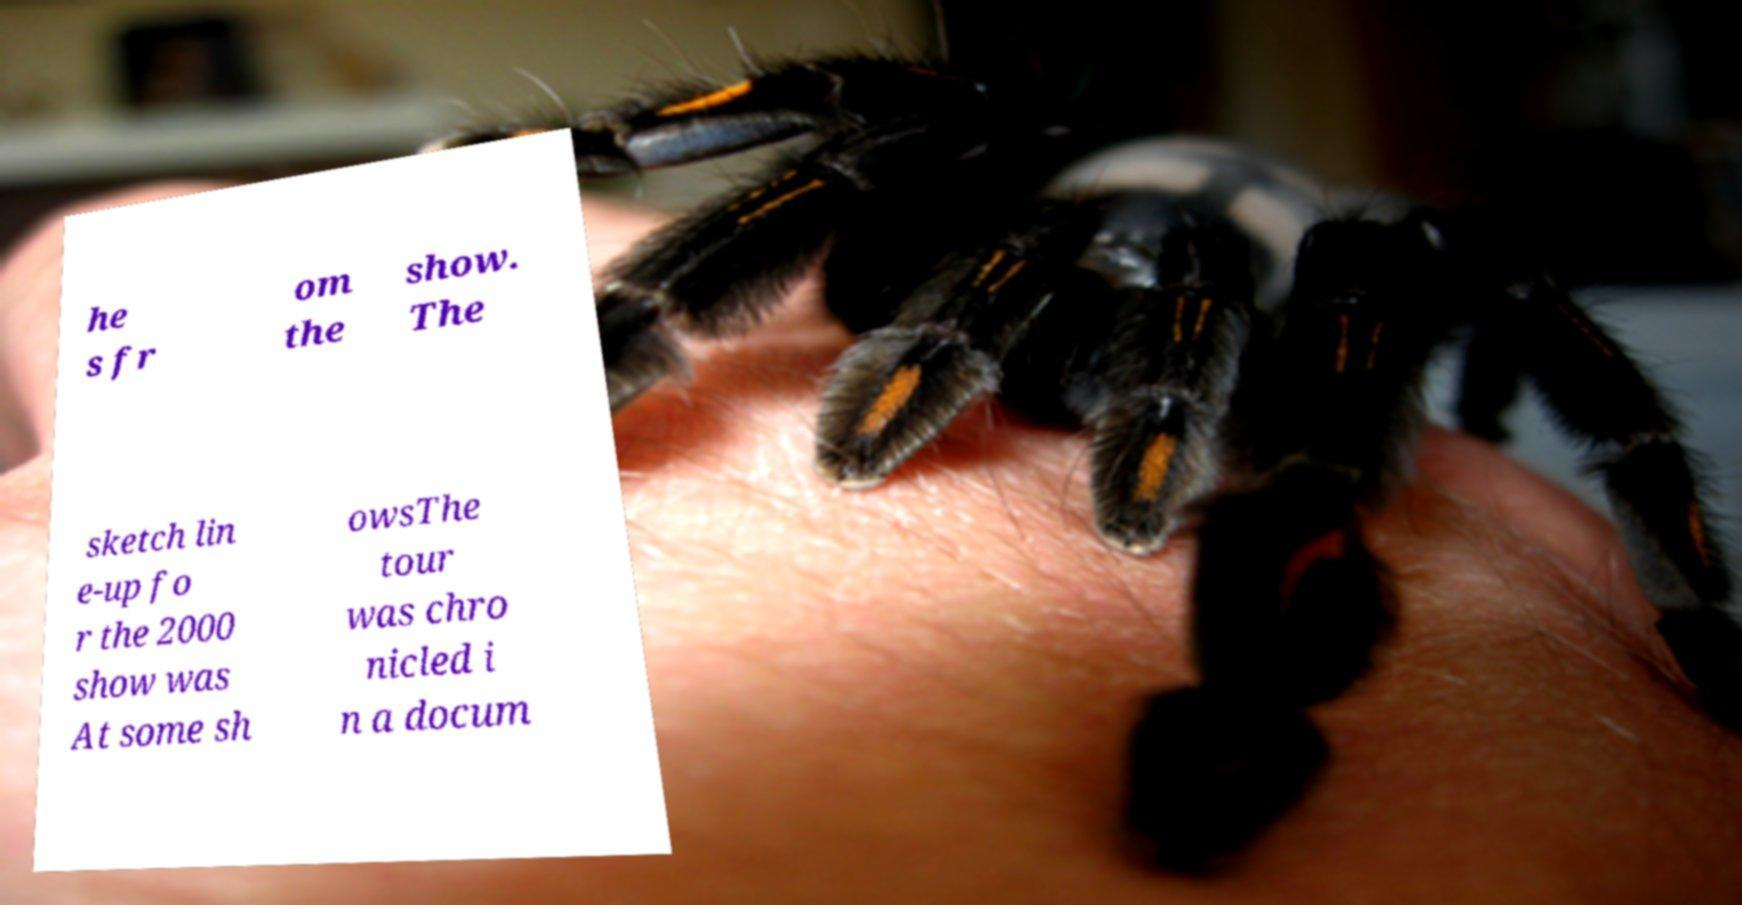I need the written content from this picture converted into text. Can you do that? he s fr om the show. The sketch lin e-up fo r the 2000 show was At some sh owsThe tour was chro nicled i n a docum 